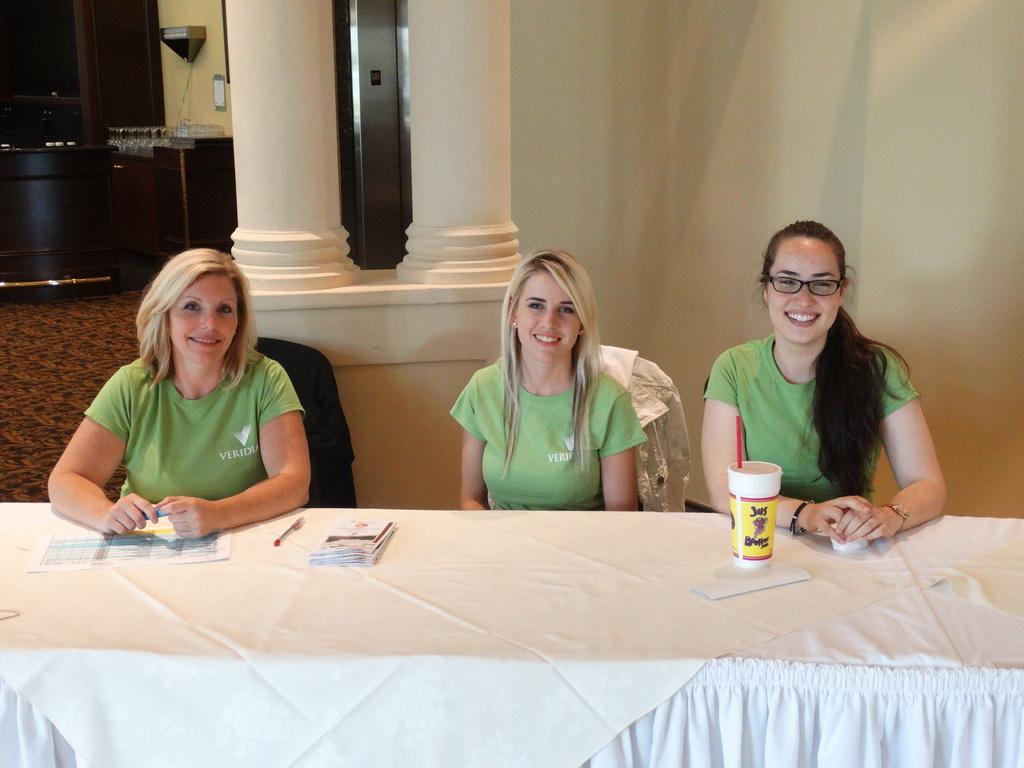Please provide a concise description of this image. As we can see in the image, there is a white color wall, three people sitting on chairs. In front of them there is a table. On table there is a paper, pen and a glass. 